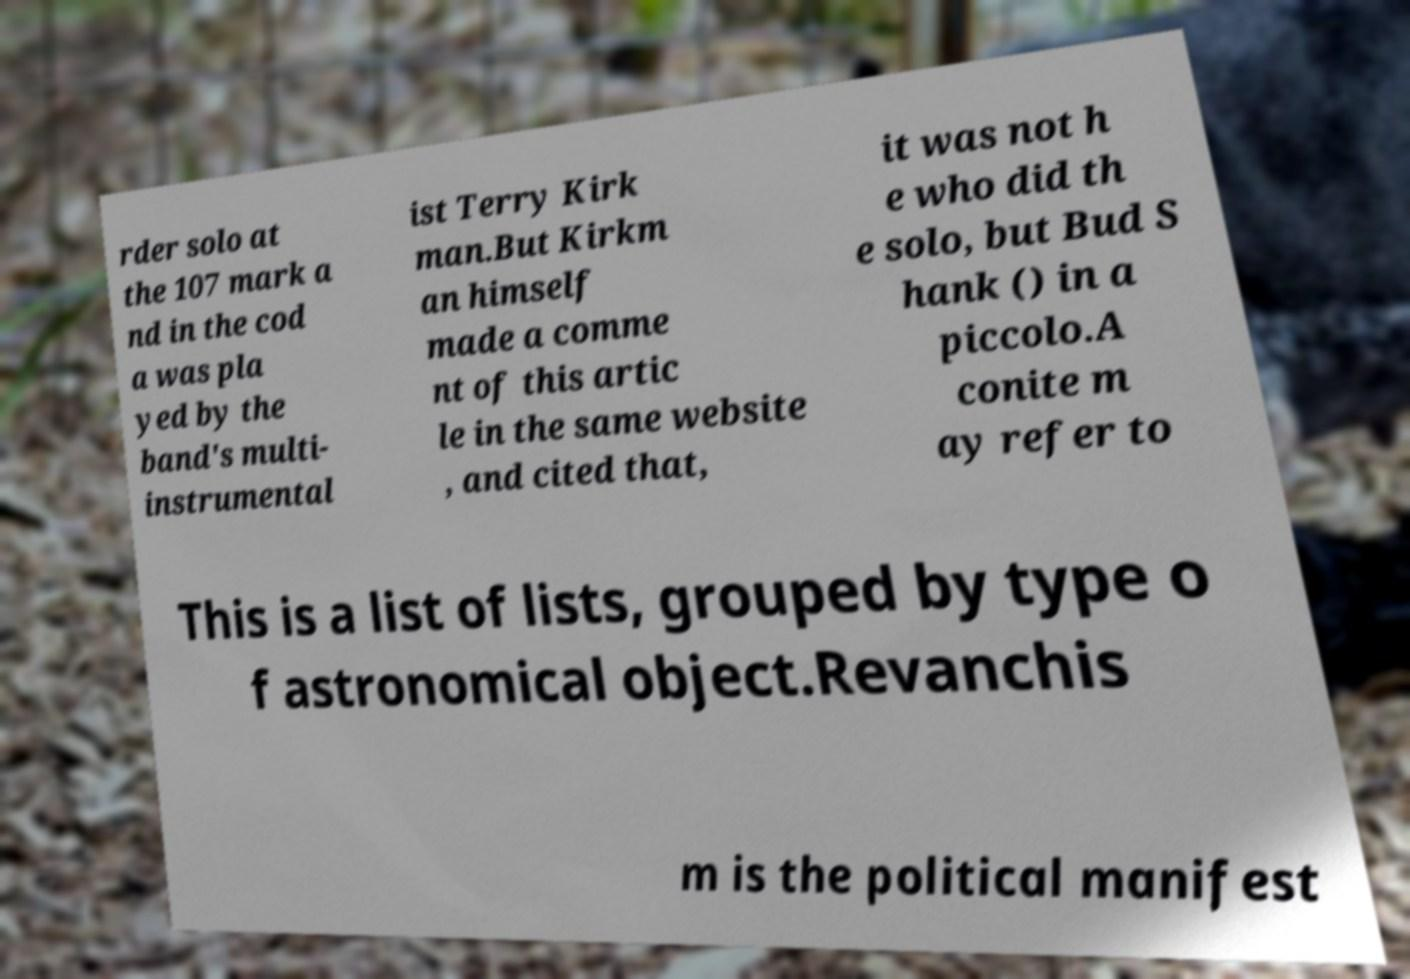Could you extract and type out the text from this image? rder solo at the 107 mark a nd in the cod a was pla yed by the band's multi- instrumental ist Terry Kirk man.But Kirkm an himself made a comme nt of this artic le in the same website , and cited that, it was not h e who did th e solo, but Bud S hank () in a piccolo.A conite m ay refer to This is a list of lists, grouped by type o f astronomical object.Revanchis m is the political manifest 